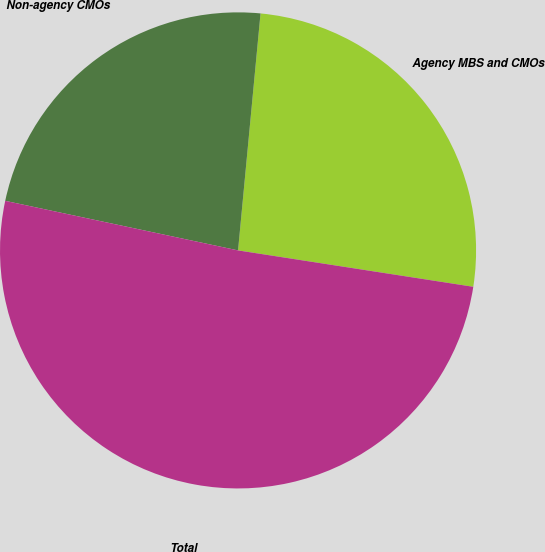<chart> <loc_0><loc_0><loc_500><loc_500><pie_chart><fcel>Agency MBS and CMOs<fcel>Non-agency CMOs<fcel>Total<nl><fcel>25.94%<fcel>23.17%<fcel>50.9%<nl></chart> 